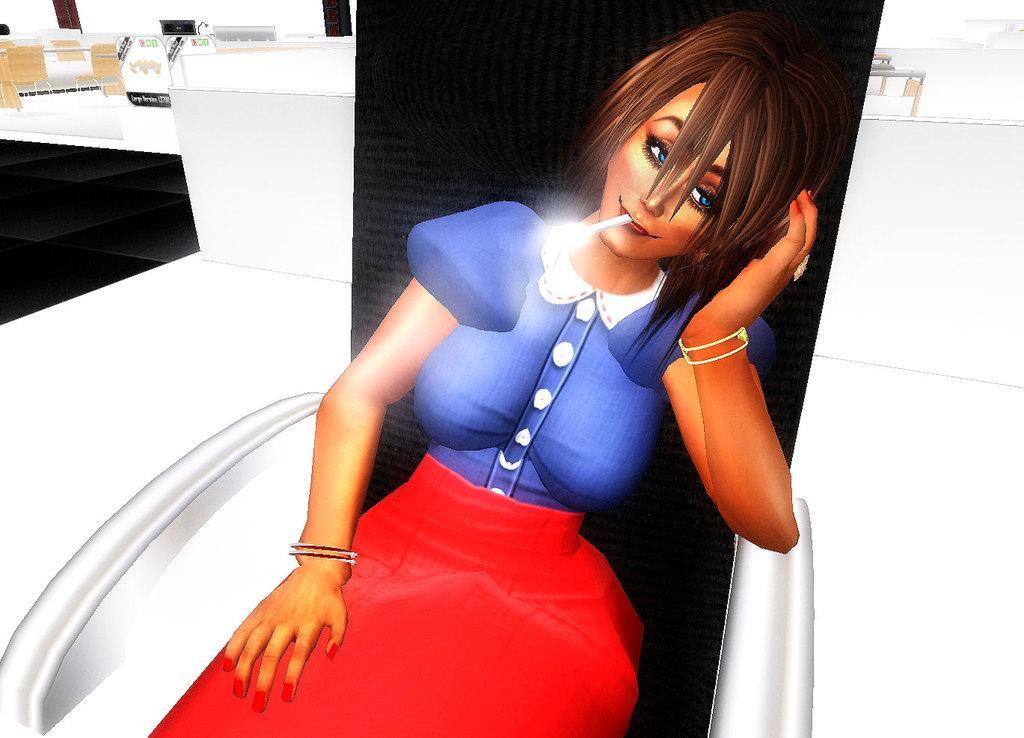Could you give a brief overview of what you see in this image? This is an animated image. In this image there is a lady placed a cigarette in her mouth and sitting on the chair, beside her there are few tables, chairs, monitor and a few other objects. 